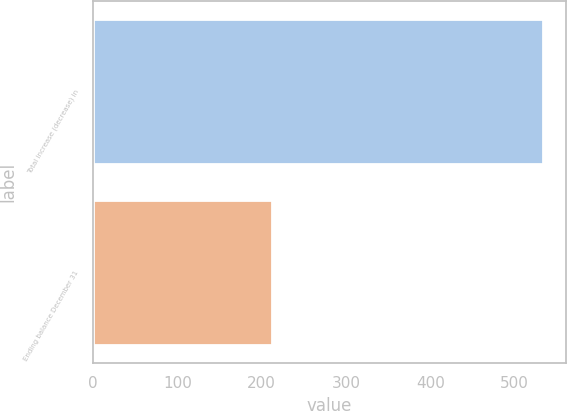<chart> <loc_0><loc_0><loc_500><loc_500><bar_chart><fcel>Total increase (decrease) in<fcel>Ending balance December 31<nl><fcel>534<fcel>212<nl></chart> 